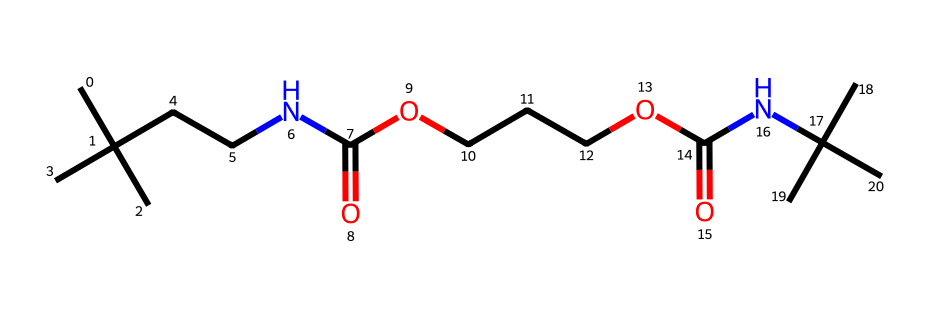What is the main functional group present in this chemical? Analyzing the structure, it contains amine groups (–NH) and carboxylic acid groups (–COOH), with distinct branching at the ends. This indicates that both amides and esters may also be present. The primary functional group shown is the carboxylic acid.
Answer: carboxylic acid How many nitrogen atoms are in this molecule? By examining the structure, we identify two nitrogen atoms present in the amine and amide sections of the compound. This is evident from the two distinct nitrogen symbols in the representation.
Answer: 2 What type of polymer structure is represented by this molecule? This compound represents a cross-linked structure common in polyurethanes. The multiple functional groups such as isocyanate and alcohol arms link together to form a network, indicating that cross-linking occurs.
Answer: cross-linked How many carbon atoms are present in this molecule? Counting all carbon atoms represented in the structure carefully, we find 12 carbon atoms surrounding the functional groups and the backbone of the compound.
Answer: 12 What property does cross-linking provide to polyurethane foam? Cross-linking enhances the mechanical stability and resilience of the foam structure, which is crucial for maintaining its shape and firmness, providing support in mattress applications.
Answer: stability What role do the ester groups play in this polymer? The ester groups in this polymer contribute to the flexibility and durability of the foam, making it adaptable in response to pressure and providing comfort in mattress formulations.
Answer: flexibility 